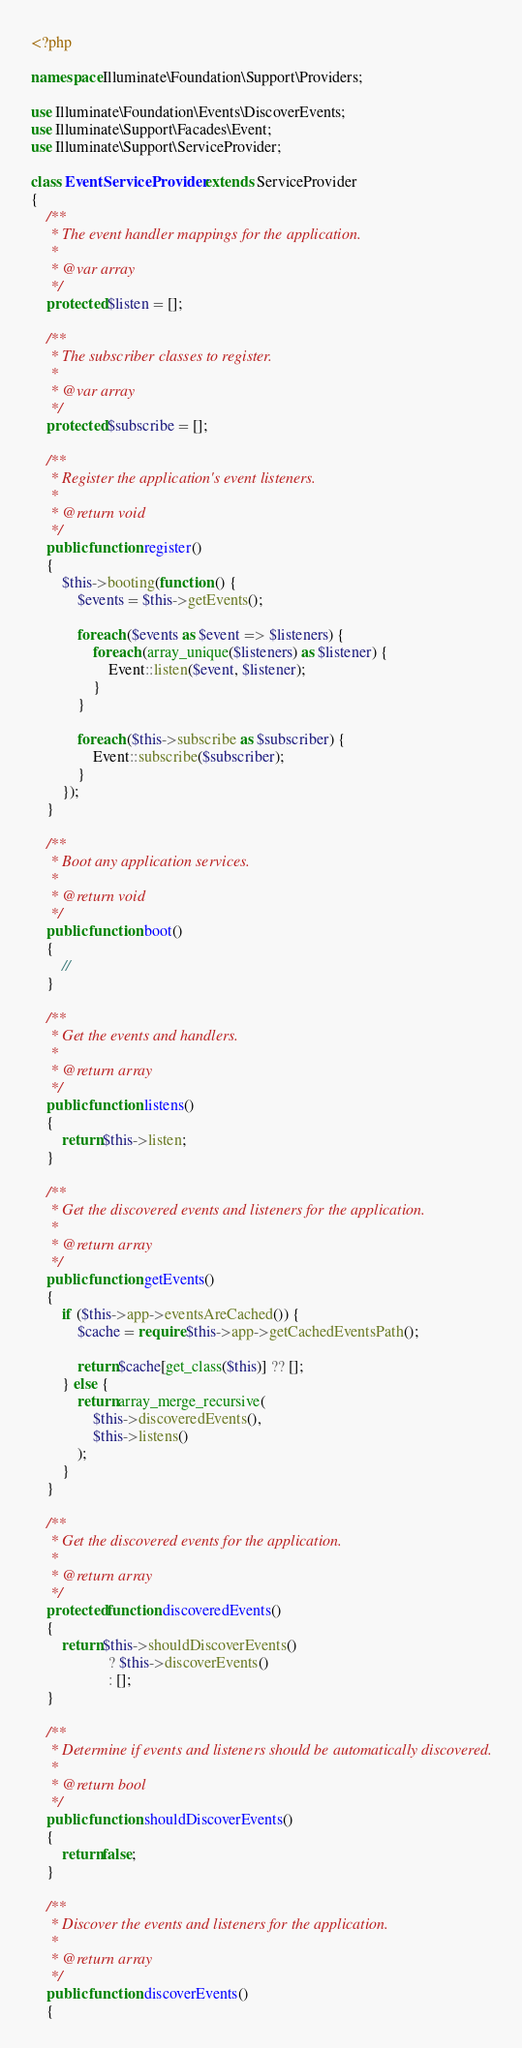Convert code to text. <code><loc_0><loc_0><loc_500><loc_500><_PHP_><?php

namespace Illuminate\Foundation\Support\Providers;

use Illuminate\Foundation\Events\DiscoverEvents;
use Illuminate\Support\Facades\Event;
use Illuminate\Support\ServiceProvider;

class EventServiceProvider extends ServiceProvider
{
    /**
     * The event handler mappings for the application.
     *
     * @var array
     */
    protected $listen = [];

    /**
     * The subscriber classes to register.
     *
     * @var array
     */
    protected $subscribe = [];

    /**
     * Register the application's event listeners.
     *
     * @return void
     */
    public function register()
    {
        $this->booting(function () {
            $events = $this->getEvents();

            foreach ($events as $event => $listeners) {
                foreach (array_unique($listeners) as $listener) {
                    Event::listen($event, $listener);
                }
            }

            foreach ($this->subscribe as $subscriber) {
                Event::subscribe($subscriber);
            }
        });
    }

    /**
     * Boot any application services.
     *
     * @return void
     */
    public function boot()
    {
        //
    }

    /**
     * Get the events and handlers.
     *
     * @return array
     */
    public function listens()
    {
        return $this->listen;
    }

    /**
     * Get the discovered events and listeners for the application.
     *
     * @return array
     */
    public function getEvents()
    {
        if ($this->app->eventsAreCached()) {
            $cache = require $this->app->getCachedEventsPath();

            return $cache[get_class($this)] ?? [];
        } else {
            return array_merge_recursive(
                $this->discoveredEvents(),
                $this->listens()
            );
        }
    }

    /**
     * Get the discovered events for the application.
     *
     * @return array
     */
    protected function discoveredEvents()
    {
        return $this->shouldDiscoverEvents()
                    ? $this->discoverEvents()
                    : [];
    }

    /**
     * Determine if events and listeners should be automatically discovered.
     *
     * @return bool
     */
    public function shouldDiscoverEvents()
    {
        return false;
    }

    /**
     * Discover the events and listeners for the application.
     *
     * @return array
     */
    public function discoverEvents()
    {</code> 